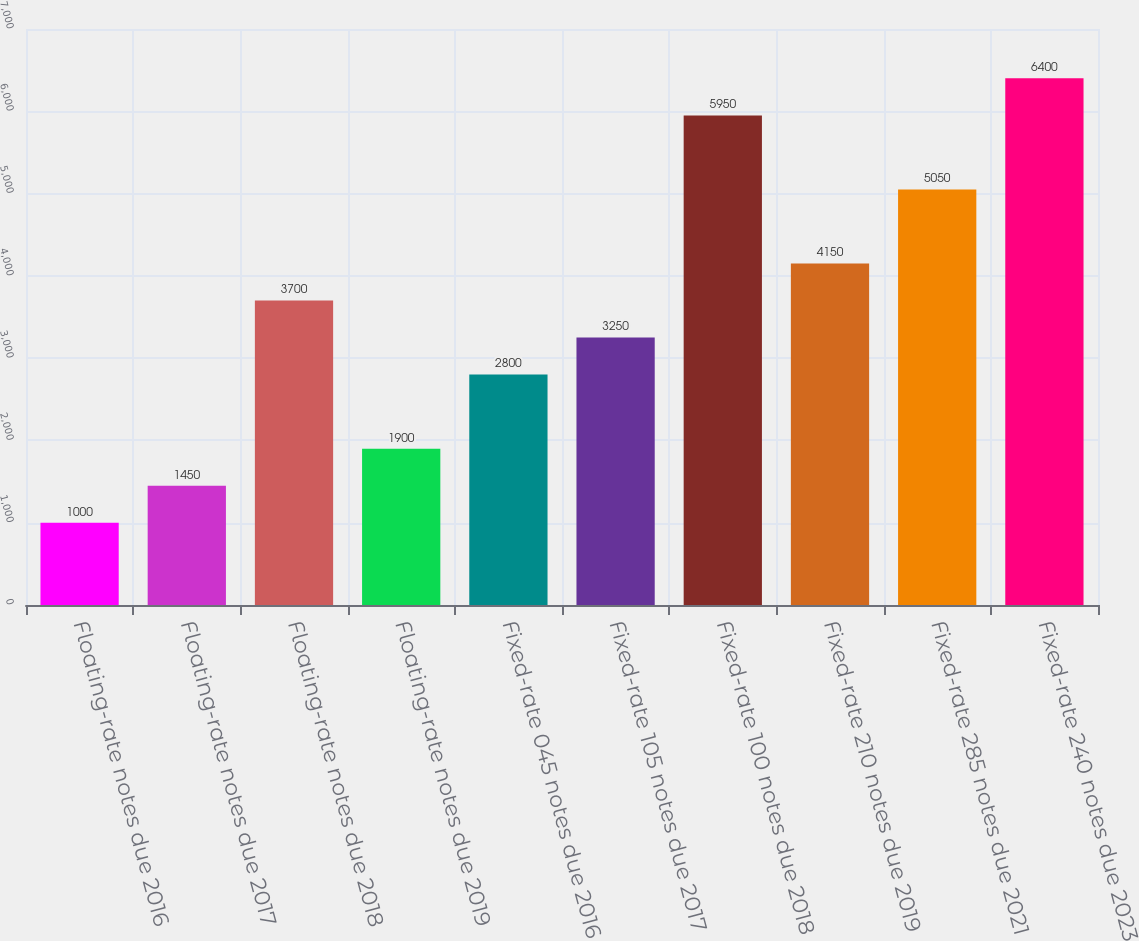<chart> <loc_0><loc_0><loc_500><loc_500><bar_chart><fcel>Floating-rate notes due 2016<fcel>Floating-rate notes due 2017<fcel>Floating-rate notes due 2018<fcel>Floating-rate notes due 2019<fcel>Fixed-rate 045 notes due 2016<fcel>Fixed-rate 105 notes due 2017<fcel>Fixed-rate 100 notes due 2018<fcel>Fixed-rate 210 notes due 2019<fcel>Fixed-rate 285 notes due 2021<fcel>Fixed-rate 240 notes due 2023<nl><fcel>1000<fcel>1450<fcel>3700<fcel>1900<fcel>2800<fcel>3250<fcel>5950<fcel>4150<fcel>5050<fcel>6400<nl></chart> 